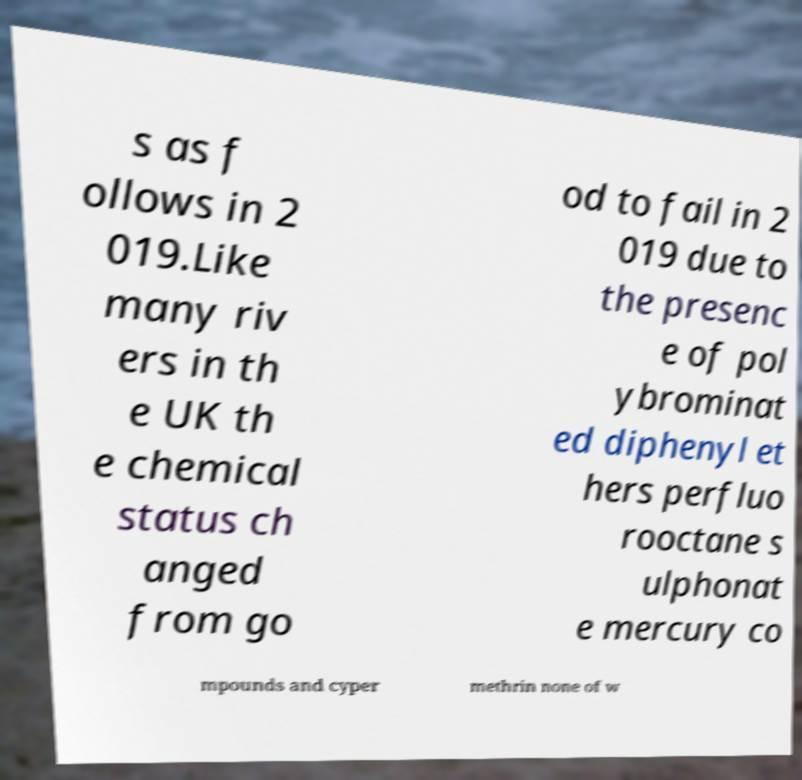Can you accurately transcribe the text from the provided image for me? s as f ollows in 2 019.Like many riv ers in th e UK th e chemical status ch anged from go od to fail in 2 019 due to the presenc e of pol ybrominat ed diphenyl et hers perfluo rooctane s ulphonat e mercury co mpounds and cyper methrin none of w 